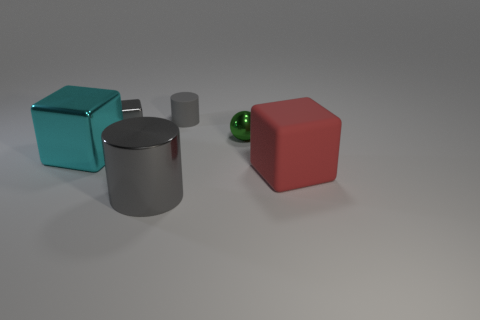Is there a matte block of the same size as the green thing? Yes, there is a red block that appears to have the same size as the green spherical object. 